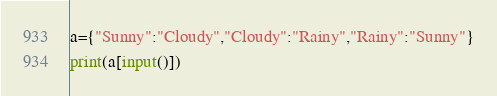Convert code to text. <code><loc_0><loc_0><loc_500><loc_500><_Python_>a={"Sunny":"Cloudy","Cloudy":"Rainy","Rainy":"Sunny"}
print(a[input()])</code> 